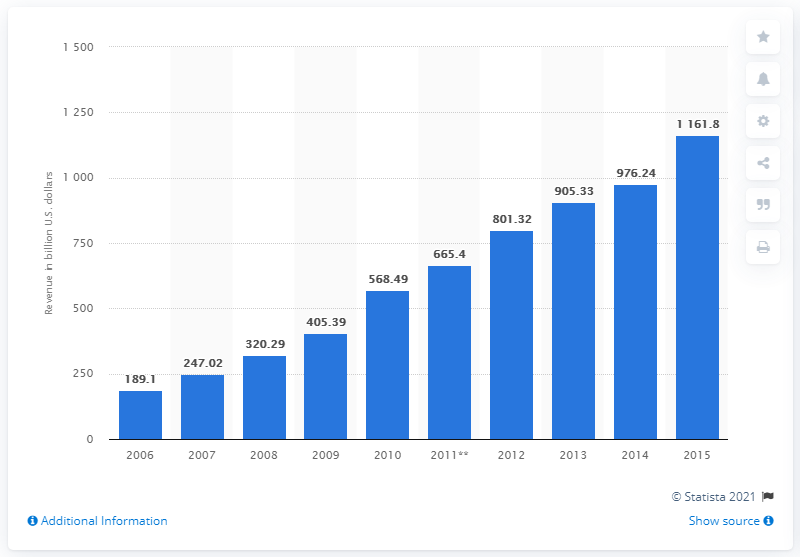Draw attention to some important aspects in this diagram. In 2015, the Chinese market for mechanical engineering was estimated to be 1161.8 billion U.S. dollars. In 2015, the value of the Chinese market for mechanical engineering was 976.24.. 